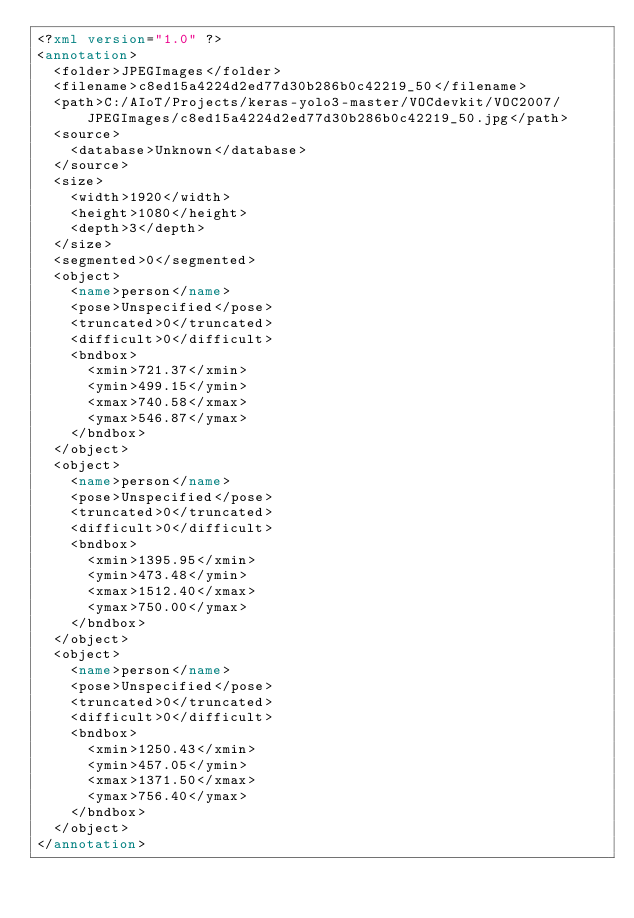<code> <loc_0><loc_0><loc_500><loc_500><_XML_><?xml version="1.0" ?>
<annotation>
	<folder>JPEGImages</folder>
	<filename>c8ed15a4224d2ed77d30b286b0c42219_50</filename>
	<path>C:/AIoT/Projects/keras-yolo3-master/VOCdevkit/VOC2007/JPEGImages/c8ed15a4224d2ed77d30b286b0c42219_50.jpg</path>
	<source>
		<database>Unknown</database>
	</source>
	<size>
		<width>1920</width>
		<height>1080</height>
		<depth>3</depth>
	</size>
	<segmented>0</segmented>
	<object>
		<name>person</name>
		<pose>Unspecified</pose>
		<truncated>0</truncated>
		<difficult>0</difficult>
		<bndbox>
			<xmin>721.37</xmin>
			<ymin>499.15</ymin>
			<xmax>740.58</xmax>
			<ymax>546.87</ymax>
		</bndbox>
	</object>
	<object>
		<name>person</name>
		<pose>Unspecified</pose>
		<truncated>0</truncated>
		<difficult>0</difficult>
		<bndbox>
			<xmin>1395.95</xmin>
			<ymin>473.48</ymin>
			<xmax>1512.40</xmax>
			<ymax>750.00</ymax>
		</bndbox>
	</object>
	<object>
		<name>person</name>
		<pose>Unspecified</pose>
		<truncated>0</truncated>
		<difficult>0</difficult>
		<bndbox>
			<xmin>1250.43</xmin>
			<ymin>457.05</ymin>
			<xmax>1371.50</xmax>
			<ymax>756.40</ymax>
		</bndbox>
	</object>
</annotation>
</code> 